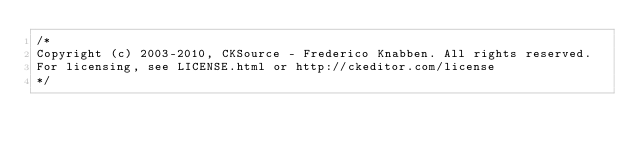<code> <loc_0><loc_0><loc_500><loc_500><_CSS_>/*
Copyright (c) 2003-2010, CKSource - Frederico Knabben. All rights reserved.
For licensing, see LICENSE.html or http://ckeditor.com/license
*/
</code> 